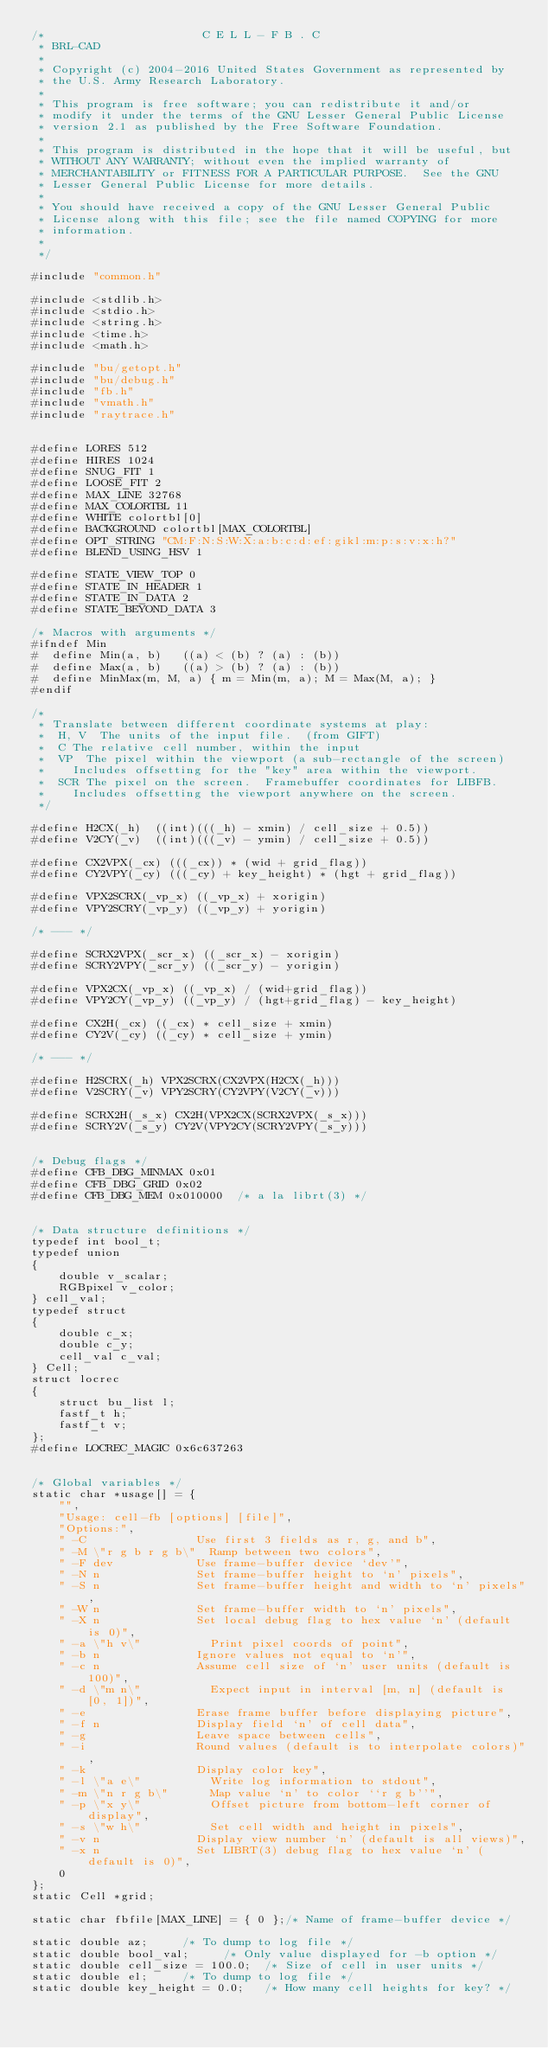<code> <loc_0><loc_0><loc_500><loc_500><_C_>/*                       C E L L - F B . C
 * BRL-CAD
 *
 * Copyright (c) 2004-2016 United States Government as represented by
 * the U.S. Army Research Laboratory.
 *
 * This program is free software; you can redistribute it and/or
 * modify it under the terms of the GNU Lesser General Public License
 * version 2.1 as published by the Free Software Foundation.
 *
 * This program is distributed in the hope that it will be useful, but
 * WITHOUT ANY WARRANTY; without even the implied warranty of
 * MERCHANTABILITY or FITNESS FOR A PARTICULAR PURPOSE.  See the GNU
 * Lesser General Public License for more details.
 *
 * You should have received a copy of the GNU Lesser General Public
 * License along with this file; see the file named COPYING for more
 * information.
 *
 */

#include "common.h"

#include <stdlib.h>
#include <stdio.h>
#include <string.h>
#include <time.h>
#include <math.h>

#include "bu/getopt.h"
#include "bu/debug.h"
#include "fb.h"
#include "vmath.h"
#include "raytrace.h"


#define LORES 512
#define HIRES 1024
#define SNUG_FIT 1
#define LOOSE_FIT 2
#define MAX_LINE 32768
#define MAX_COLORTBL 11
#define WHITE colortbl[0]
#define BACKGROUND colortbl[MAX_COLORTBL]
#define OPT_STRING "CM:F:N:S:W:X:a:b:c:d:ef:gikl:m:p:s:v:x:h?"
#define BLEND_USING_HSV 1

#define STATE_VIEW_TOP 0
#define STATE_IN_HEADER 1
#define STATE_IN_DATA 2
#define STATE_BEYOND_DATA 3

/* Macros with arguments */
#ifndef Min
#  define Min(a, b)		((a) < (b) ? (a) : (b))
#  define Max(a, b)		((a) > (b) ? (a) : (b))
#  define MinMax(m, M, a) { m = Min(m, a); M = Max(M, a); }
#endif

/*
 * Translate between different coordinate systems at play:
 *	H, V	The units of the input file.  (from GIFT)
 *	C	The relative cell number, within the input
 *	VP	The pixel within the viewport (a sub-rectangle of the screen)
 *		Includes offsetting for the "key" area within the viewport.
 *	SCR	The pixel on the screen.  Framebuffer coordinates for LIBFB.
 *		Includes offsetting the viewport anywhere on the screen.
 */

#define H2CX(_h)	((int)(((_h) - xmin) / cell_size + 0.5))
#define V2CY(_v)	((int)(((_v) - ymin) / cell_size + 0.5))

#define CX2VPX(_cx)	(((_cx)) * (wid + grid_flag))
#define CY2VPY(_cy)	(((_cy) + key_height) * (hgt + grid_flag))

#define VPX2SCRX(_vp_x)	((_vp_x) + xorigin)
#define VPY2SCRY(_vp_y)	((_vp_y) + yorigin)

/* --- */

#define SCRX2VPX(_scr_x) ((_scr_x) - xorigin)
#define SCRY2VPY(_scr_y) ((_scr_y) - yorigin)

#define VPX2CX(_vp_x)	((_vp_x) / (wid+grid_flag))
#define VPY2CY(_vp_y)	((_vp_y) / (hgt+grid_flag) - key_height)

#define CX2H(_cx)	((_cx) * cell_size + xmin)
#define CY2V(_cy)	((_cy) * cell_size + ymin)

/* --- */

#define H2SCRX(_h) VPX2SCRX(CX2VPX(H2CX(_h)))
#define V2SCRY(_v) VPY2SCRY(CY2VPY(V2CY(_v)))

#define SCRX2H(_s_x) CX2H(VPX2CX(SCRX2VPX(_s_x)))
#define SCRY2V(_s_y) CY2V(VPY2CY(SCRY2VPY(_s_y)))


/* Debug flags */
#define CFB_DBG_MINMAX 0x01
#define CFB_DBG_GRID 0x02
#define CFB_DBG_MEM 0x010000	/* a la librt(3) */


/* Data structure definitions */
typedef int bool_t;
typedef union
{
    double v_scalar;
    RGBpixel v_color;
} cell_val;
typedef struct
{
    double c_x;
    double c_y;
    cell_val c_val;
} Cell;
struct locrec
{
    struct bu_list l;
    fastf_t h;
    fastf_t v;
};
#define LOCREC_MAGIC 0x6c637263


/* Global variables */
static char *usage[] = {
    "",
    "Usage: cell-fb [options] [file]",
    "Options:",
    " -C                Use first 3 fields as r, g, and b",
    " -M \"r g b r g b\"  Ramp between two colors",
    " -F dev            Use frame-buffer device `dev'",
    " -N n              Set frame-buffer height to `n' pixels",
    " -S n              Set frame-buffer height and width to `n' pixels",
    " -W n              Set frame-buffer width to `n' pixels",
    " -X n              Set local debug flag to hex value `n' (default is 0)",
    " -a \"h v\"          Print pixel coords of point",
    " -b n              Ignore values not equal to `n'",
    " -c n              Assume cell size of `n' user units (default is 100)",
    " -d \"m n\"          Expect input in interval [m, n] (default is [0, 1])",
    " -e                Erase frame buffer before displaying picture",
    " -f n              Display field `n' of cell data",
    " -g                Leave space between cells",
    " -i                Round values (default is to interpolate colors)",
    " -k                Display color key",
    " -l \"a e\"          Write log information to stdout",
    " -m \"n r g b\"      Map value `n' to color ``r g b''",
    " -p \"x y\"          Offset picture from bottom-left corner of display",
    " -s \"w h\"          Set cell width and height in pixels",
    " -v n              Display view number `n' (default is all views)",
    " -x n              Set LIBRT(3) debug flag to hex value `n' (default is 0)",
    0
};
static Cell *grid;

static char fbfile[MAX_LINE] = { 0 };/* Name of frame-buffer device */

static double az;			/* To dump to log file */
static double bool_val;			/* Only value displayed for -b option */
static double cell_size = 100.0;	/* Size of cell in user units */
static double el;			/* To dump to log file */
static double key_height = 0.0;		/* How many cell heights for key? */</code> 